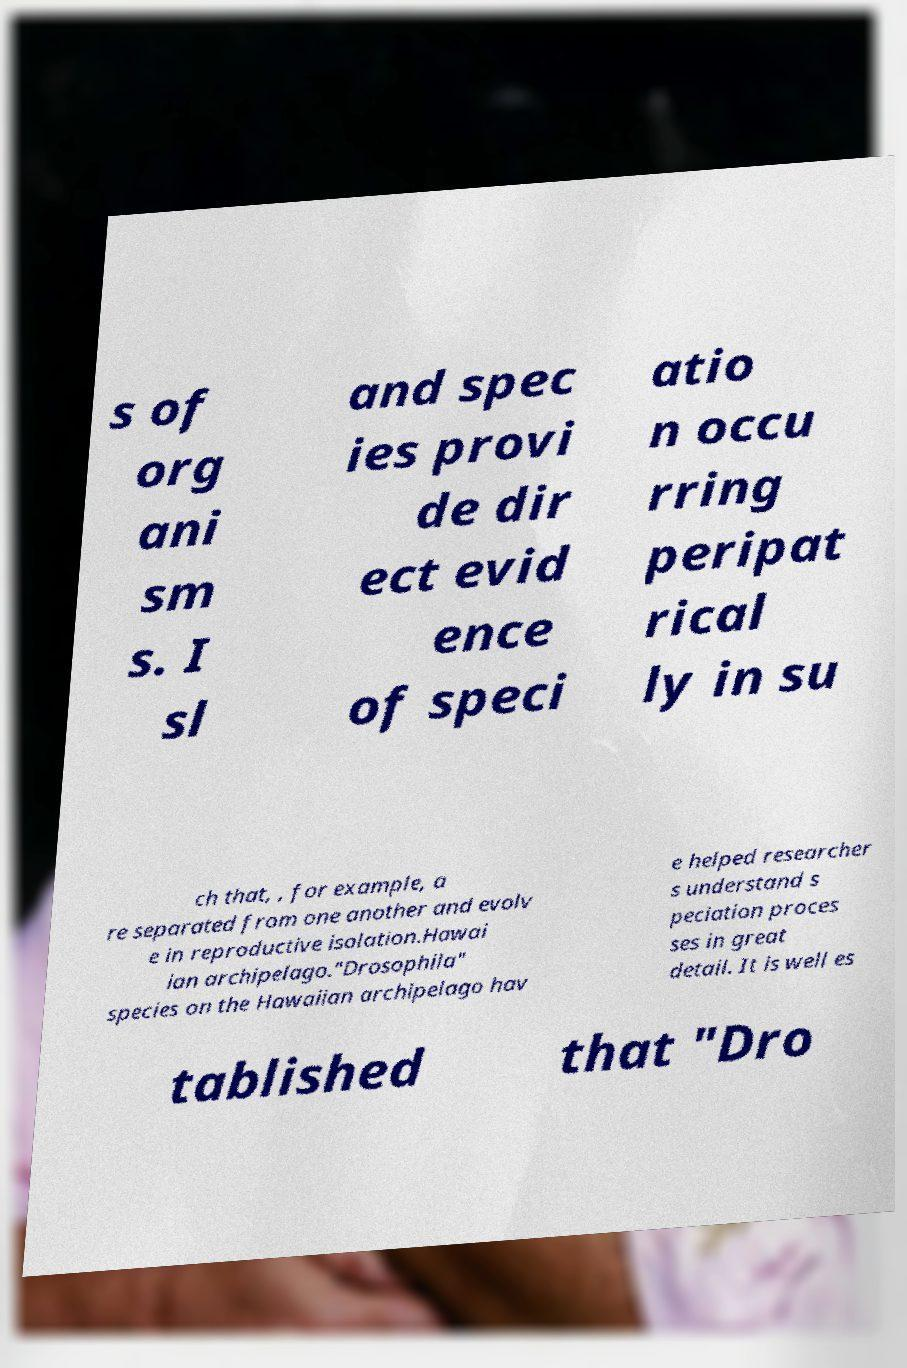For documentation purposes, I need the text within this image transcribed. Could you provide that? s of org ani sm s. I sl and spec ies provi de dir ect evid ence of speci atio n occu rring peripat rical ly in su ch that, , for example, a re separated from one another and evolv e in reproductive isolation.Hawai ian archipelago."Drosophila" species on the Hawaiian archipelago hav e helped researcher s understand s peciation proces ses in great detail. It is well es tablished that "Dro 